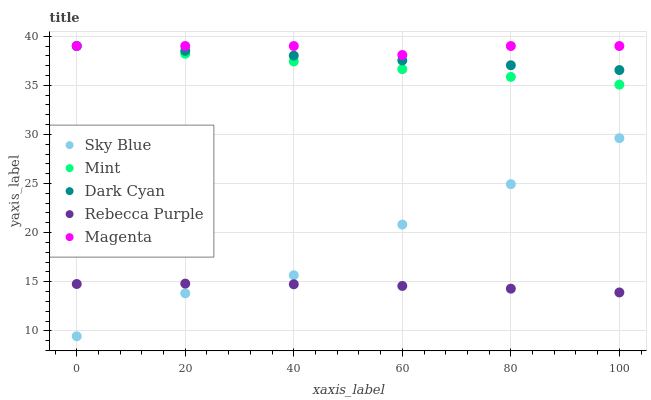Does Rebecca Purple have the minimum area under the curve?
Answer yes or no. Yes. Does Magenta have the maximum area under the curve?
Answer yes or no. Yes. Does Sky Blue have the minimum area under the curve?
Answer yes or no. No. Does Sky Blue have the maximum area under the curve?
Answer yes or no. No. Is Mint the smoothest?
Answer yes or no. Yes. Is Sky Blue the roughest?
Answer yes or no. Yes. Is Magenta the smoothest?
Answer yes or no. No. Is Magenta the roughest?
Answer yes or no. No. Does Sky Blue have the lowest value?
Answer yes or no. Yes. Does Magenta have the lowest value?
Answer yes or no. No. Does Mint have the highest value?
Answer yes or no. Yes. Does Sky Blue have the highest value?
Answer yes or no. No. Is Rebecca Purple less than Dark Cyan?
Answer yes or no. Yes. Is Magenta greater than Rebecca Purple?
Answer yes or no. Yes. Does Rebecca Purple intersect Sky Blue?
Answer yes or no. Yes. Is Rebecca Purple less than Sky Blue?
Answer yes or no. No. Is Rebecca Purple greater than Sky Blue?
Answer yes or no. No. Does Rebecca Purple intersect Dark Cyan?
Answer yes or no. No. 